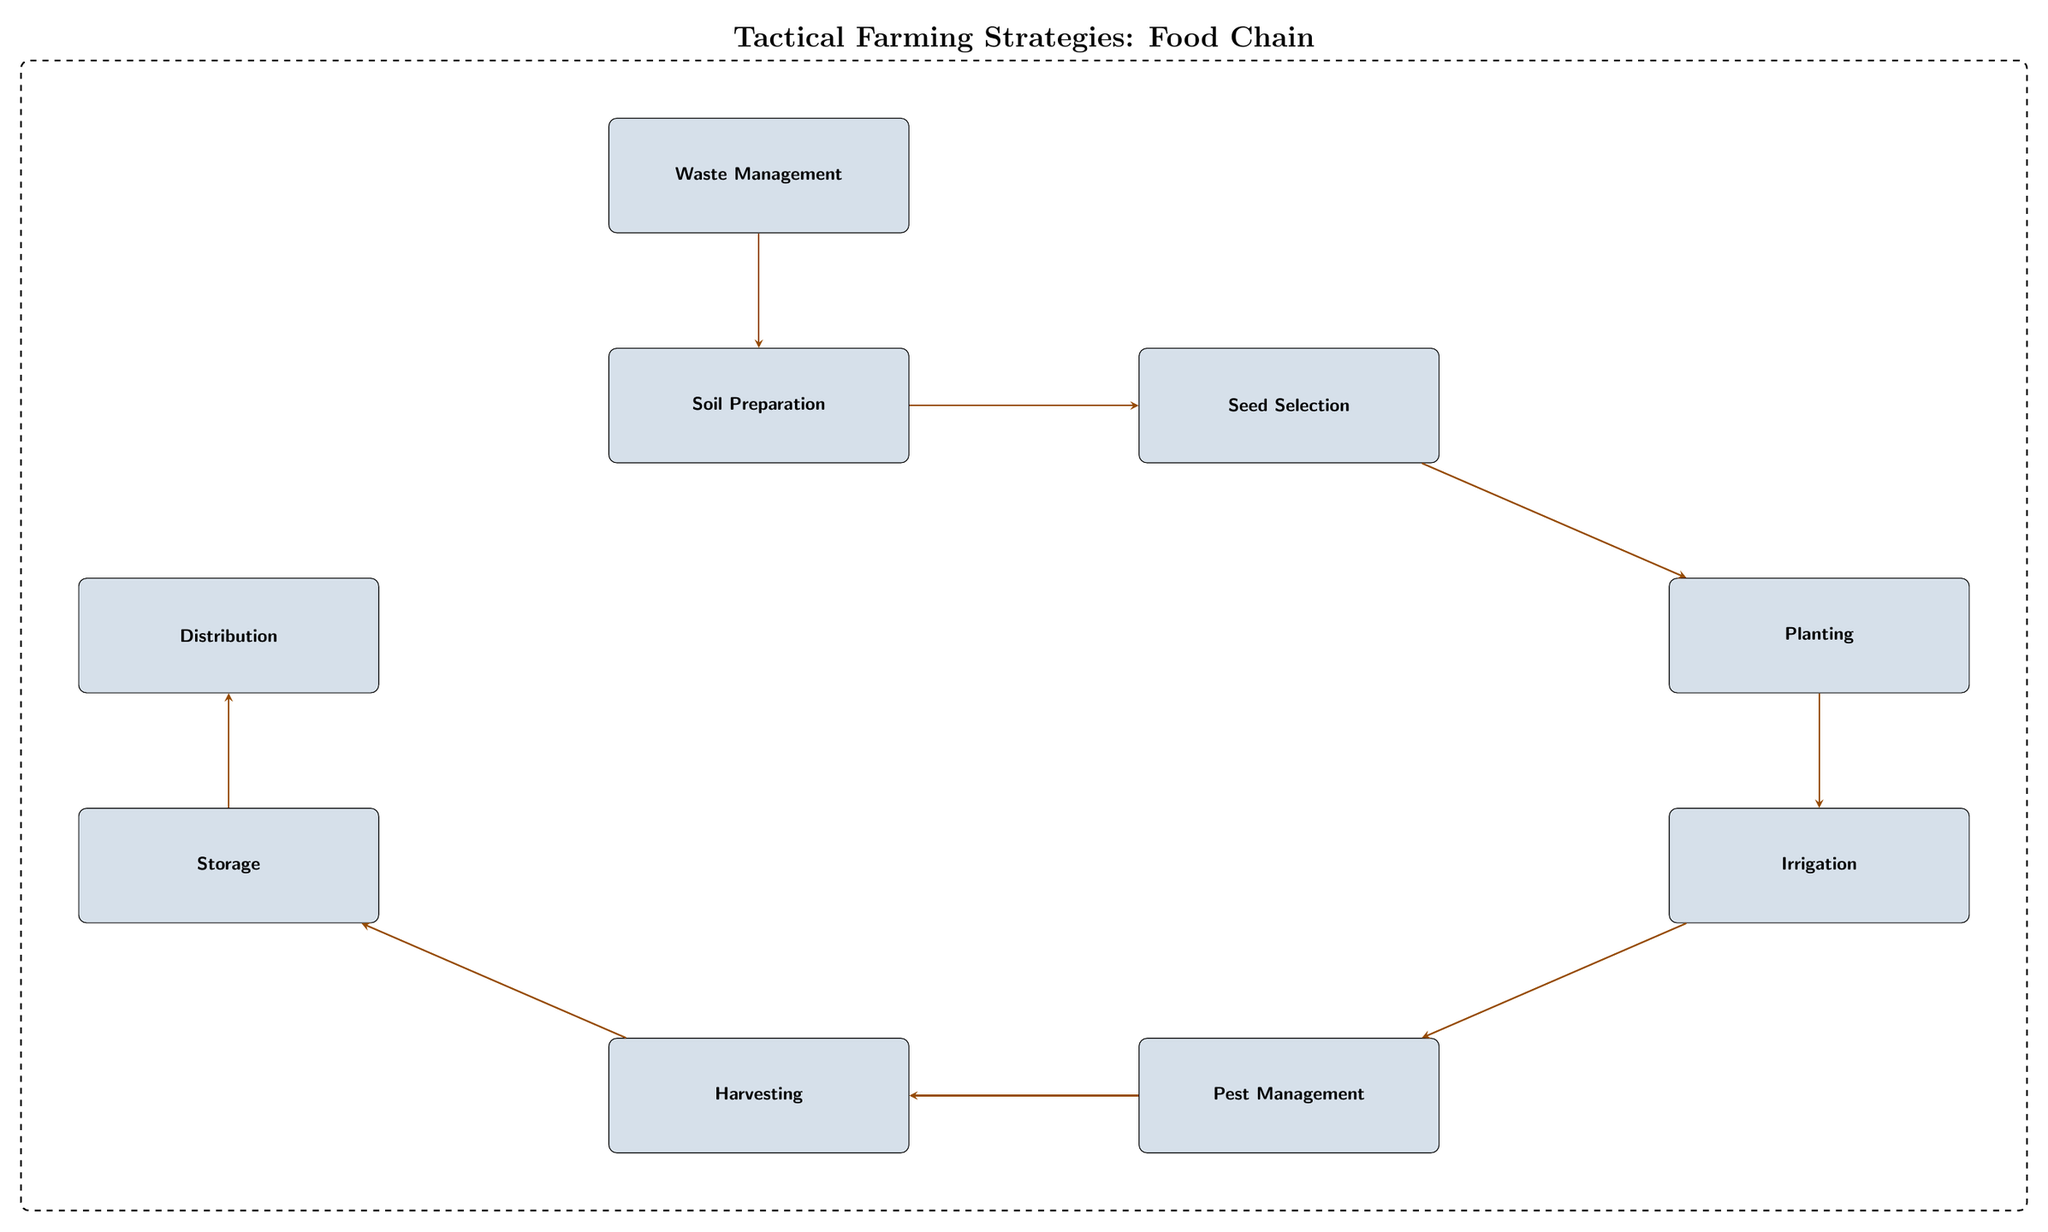What's the first step in the food chain? The first step in the food chain is "Soil Preparation," which is the starting point for the agricultural practices depicted in the diagram.
Answer: Soil Preparation How many nodes are in the diagram? By counting each distinct box in the diagram, there are eight nodes representing different stages in the food chain.
Answer: 8 What is the final step in the food chain? The final step in the food chain is "Distribution," which indicates the last stage where the harvested products are delivered.
Answer: Distribution Which processes are involved between "Irrigation" and "Harvesting"? The process in between "Irrigation" and "Harvesting" is "Pest Management," which is necessary to ensure a successful crop yield before harvesting.
Answer: Pest Management What is the relationship between "Storage" and "Distribution"? The relationship is that "Storage" feeds into "Distribution," meaning the crops are first stored and then distributed.
Answer: Storage feeds into Distribution What is the role of "Waste Management" in the food chain? "Waste Management" plays a role by creating a loop back to "Soil Preparation," indicating that waste can be used to enrich the soil.
Answer: Enriching soil How many edges connect "Planting" to "Irrigation"? There is one edge that connects "Planting" to "Irrigation," indicating the direct relationship from one process to the next.
Answer: 1 Which step involves selecting crops? The step that involves selecting crops is "Seed Selection," where appropriate seeds are chosen before planting.
Answer: Seed Selection What connects "Harvesting" to "Storage"? The connection between "Harvesting" and "Storage" is direct and denotes that harvested crops are immediately placed into storage.
Answer: Direct connection What does the dashed box in the diagram signify? The dashed box signifies the entire food chain process, enclosing all stages of agricultural practices.
Answer: Entire food chain process 